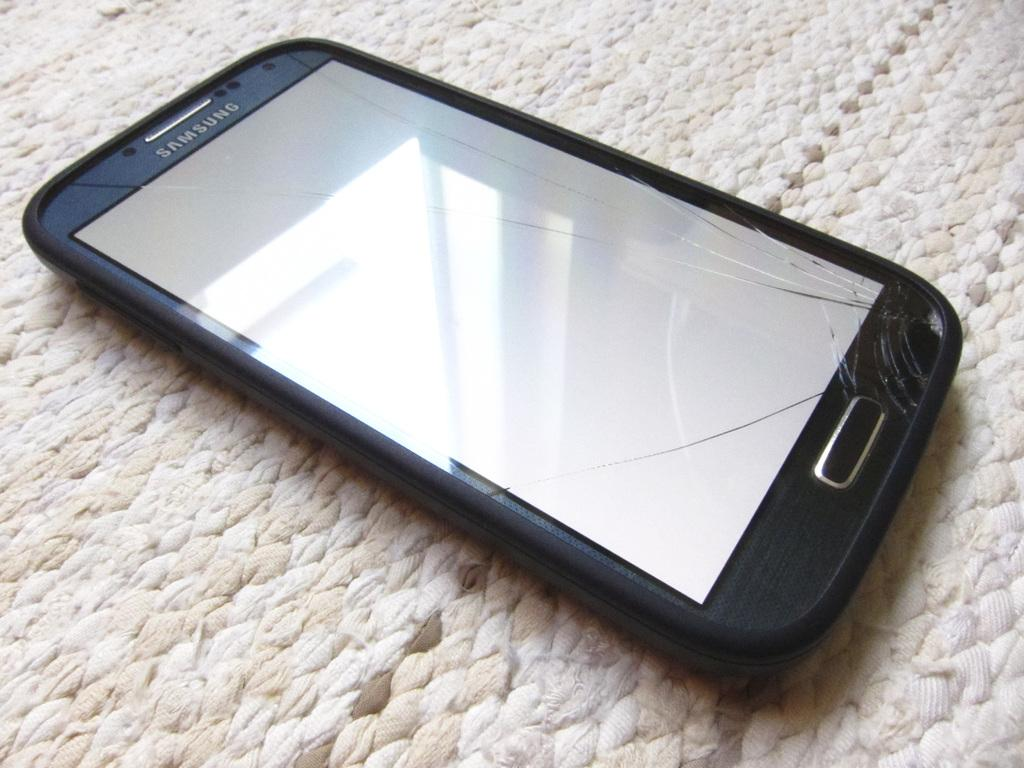<image>
Provide a brief description of the given image. a cracked screen on a samsung smart phone 